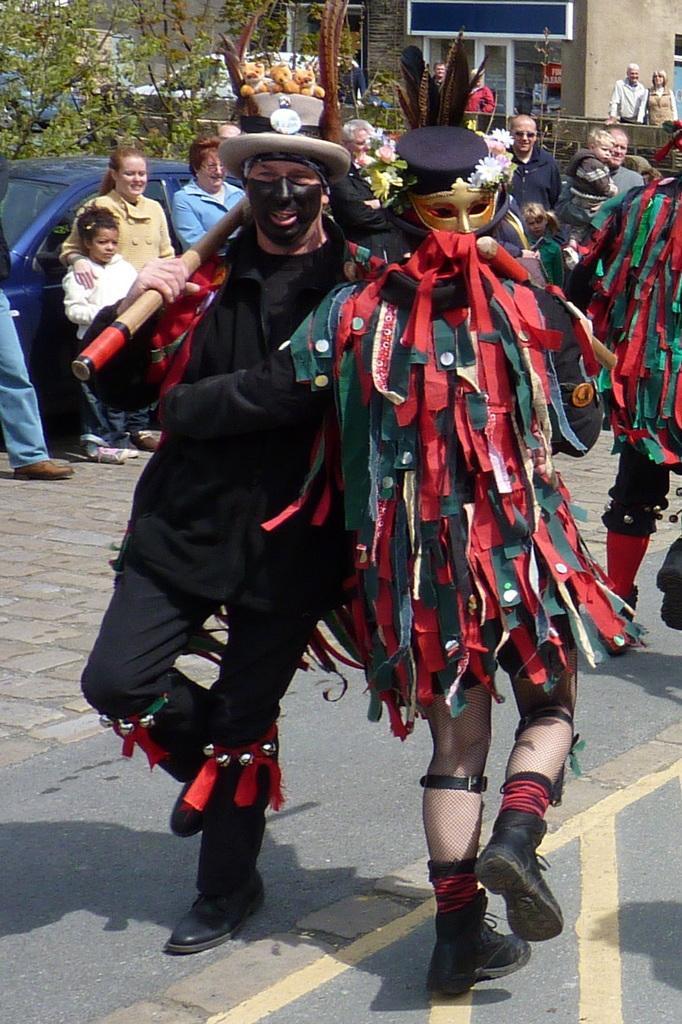How would you summarize this image in a sentence or two? In this image, we can see persons wearing clothes. There are two persons in the middle of the image wearing hats. There is a car on the left side of the image. There is a tree in the top left of the image. There is a building at the top of the image. 